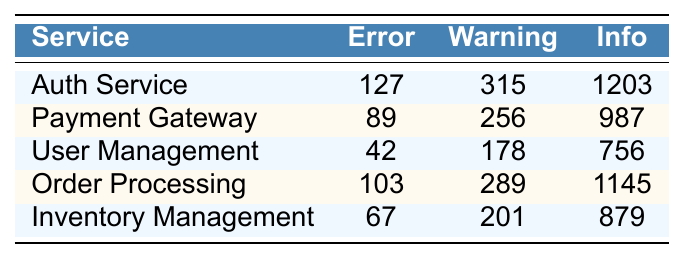What is the number of error logs for the Auth Service? The table shows that the number of error logs for the Auth Service is directly listed as 127.
Answer: 127 Which service has the highest number of warning logs? By looking through the warning log counts, Auth Service has 315 warnings, which is higher than the others.
Answer: Auth Service What is the total number of error logs across all services? To find this, sum the error counts for each service: 127 + 89 + 42 + 103 + 67 = 428.
Answer: 428 How many more info logs does the Order Processing service have compared to the Payments Gateway? The Order Processing service has 1145 info logs and the Payment Gateway has 987. The difference is 1145 - 987 = 158.
Answer: 158 Does the User Management service have more error logs than the Inventory Management service? User Management has 42 error logs, while Inventory Management has 67. Since 42 is less than 67, the statement is false.
Answer: No What is the average number of warning logs across all services? Calculate the average by summing warning logs: 315 + 256 + 178 + 289 + 201 = 1239. Then divide by the number of services (5), giving 1239/5 = 247.8.
Answer: 247.8 Which service has the lowest number of error logs? The service with the lowest error logs is User Management, with only 42 error logs, which can be seen from the table.
Answer: User Management What is the total number of logs (error, warning, and info) for Inventory Management? For Inventory Management, total logs = 67 (Error) + 201 (Warning) + 879 (Info) = 1147.
Answer: 1147 Are the total number of info logs for the Auth Service and Payment Gateway greater than the total error logs for both? Total info logs for Auth Service (1203) + Payment Gateway (987) is 2190. Total error logs for both is 127 + 89 = 216. Since 2190 > 216, the answer is yes.
Answer: Yes What is the ratio of the highest number of error logs to the lowest number of error logs among the services? The highest number of error logs is 127 (Auth Service) and the lowest is 42 (User Management). The ratio is 127:42, simplifying gives approximately 3:1.
Answer: 3:1 